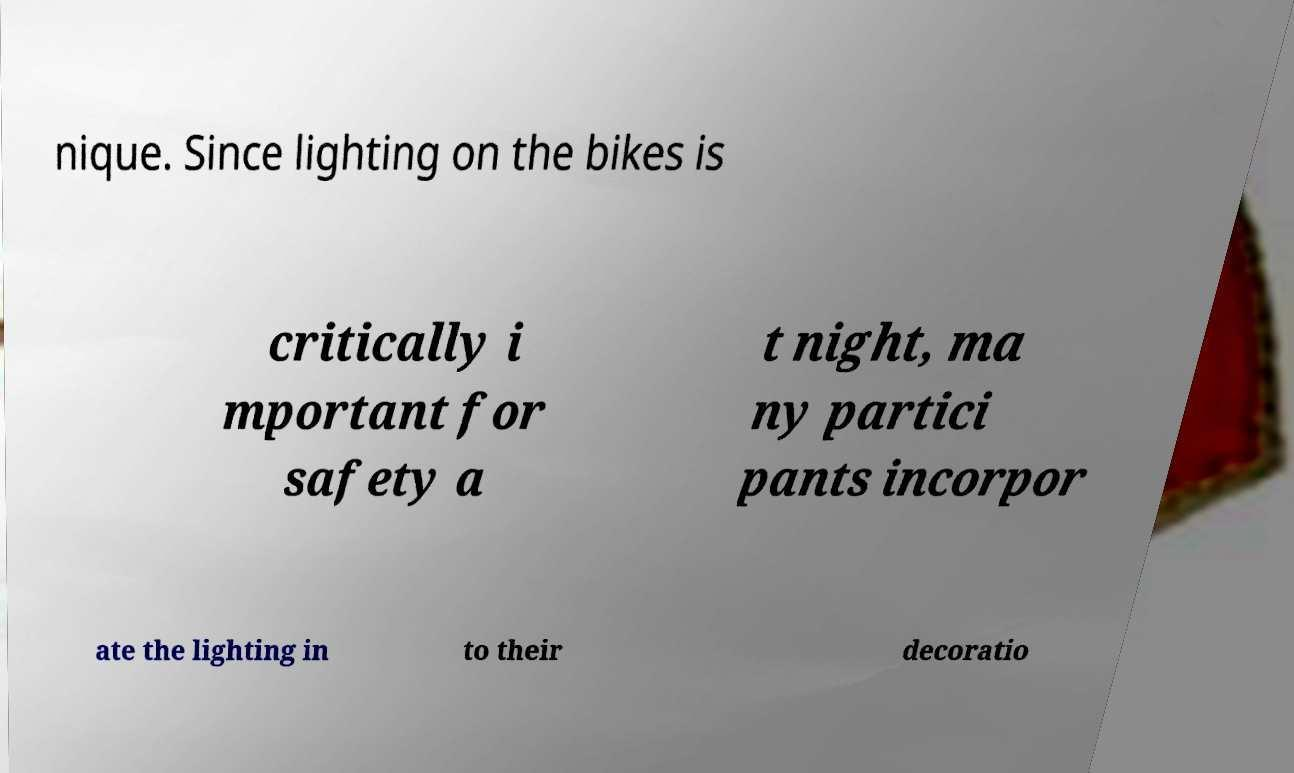What messages or text are displayed in this image? I need them in a readable, typed format. nique. Since lighting on the bikes is critically i mportant for safety a t night, ma ny partici pants incorpor ate the lighting in to their decoratio 